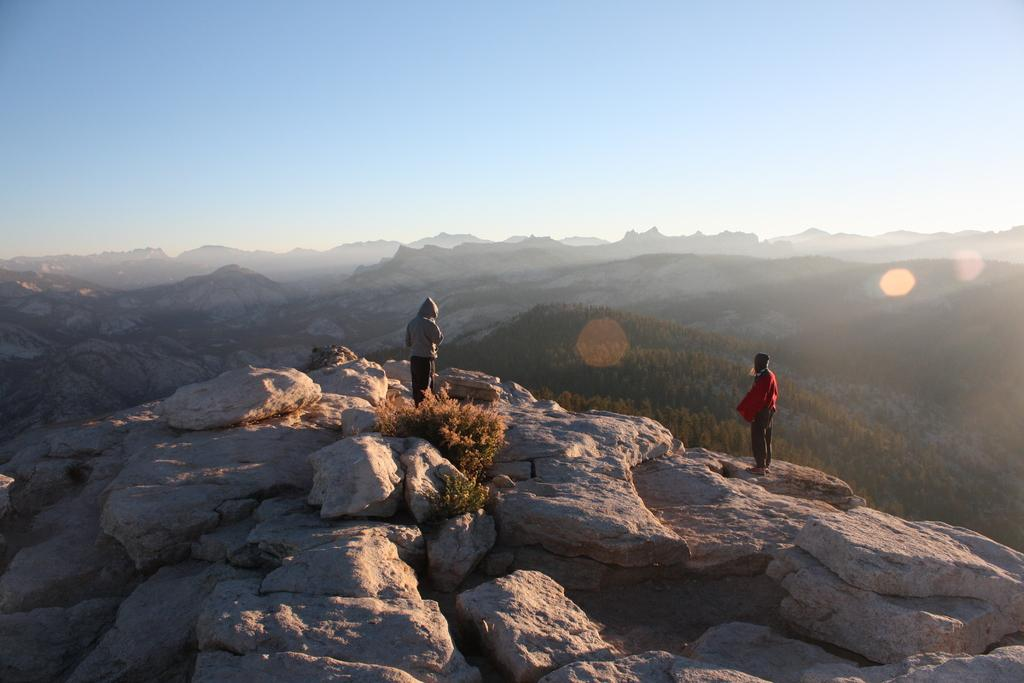How many people are in the image? There are two persons in the image. Where are the persons standing? The persons are standing on a mountain. What can be seen at the bottom of the image? There are rocks at the bottom of the image. What is visible in the background of the image? There are mountains in the background of the image. What is visible at the top of the image? The sky is visible at the top of the image. What type of flesh can be seen hanging from the church in the image? There is no church or flesh present in the image; it features two persons standing on a mountain with rocks, mountains, and sky visible. 